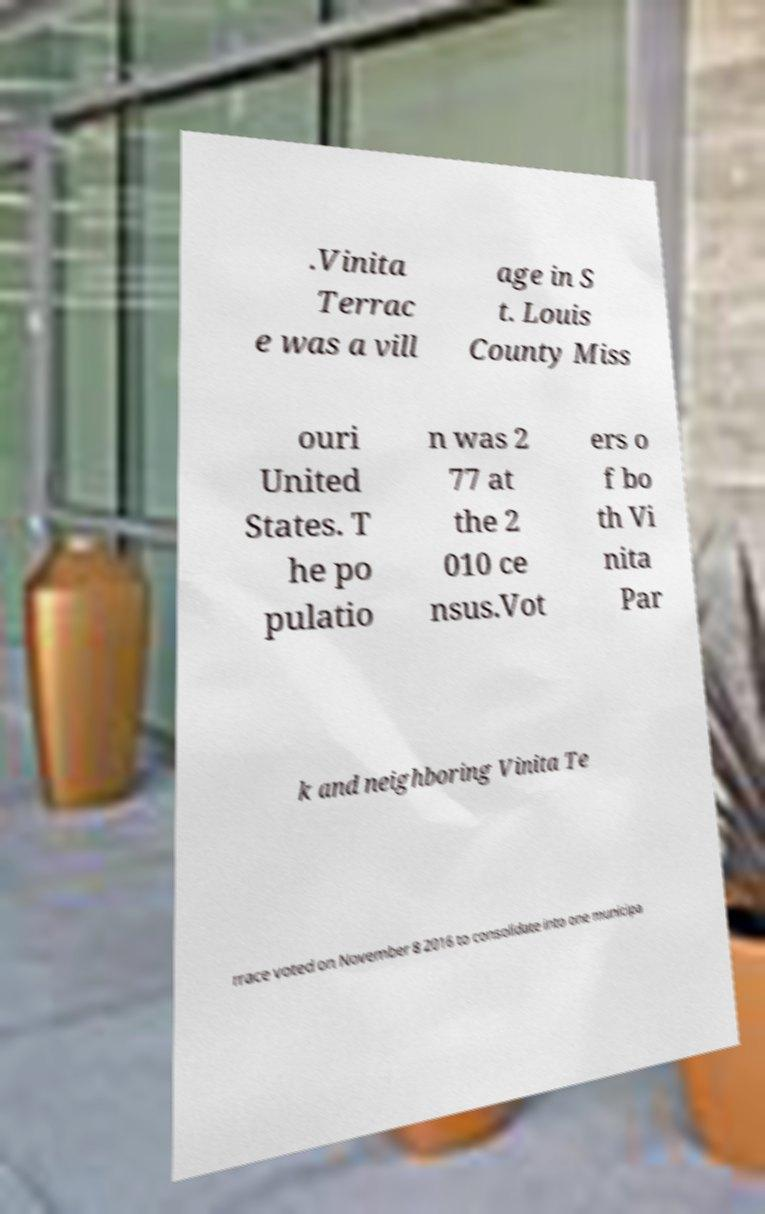Please identify and transcribe the text found in this image. .Vinita Terrac e was a vill age in S t. Louis County Miss ouri United States. T he po pulatio n was 2 77 at the 2 010 ce nsus.Vot ers o f bo th Vi nita Par k and neighboring Vinita Te rrace voted on November 8 2016 to consolidate into one municipa 